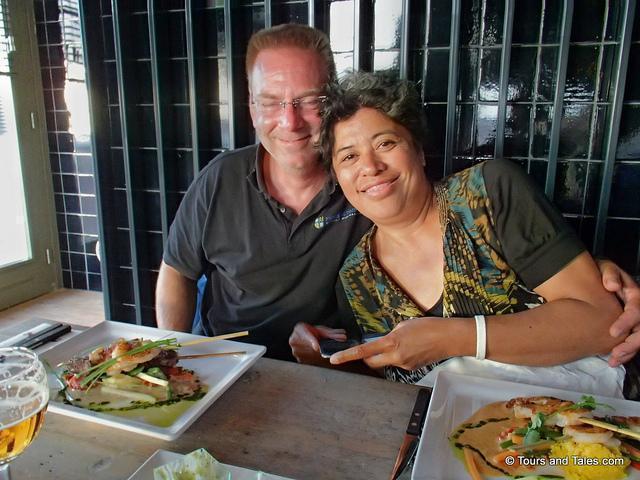What will this couple use to dine here?
Make your selection from the four choices given to correctly answer the question.
Options: Chopsticks, knives, forks, spoons. Chopsticks. How is the man's sight without assistance?
Select the accurate answer and provide justification: `Answer: choice
Rationale: srationale.`
Options: Colorblind, blind, perfect, impaired. Answer: impaired.
Rationale: Humans wear glasses because we all agreed to run the world seeing with 20/20 vision. without his glasses the man would miss out on the sizes of lettering the world commonly uses. 